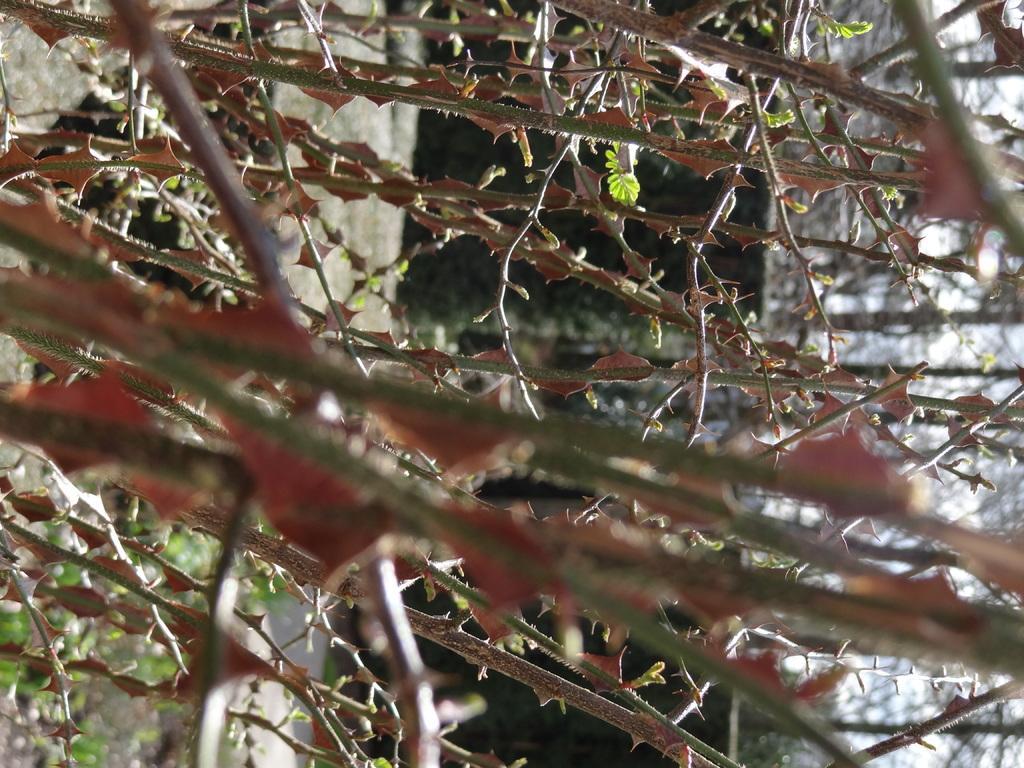Describe this image in one or two sentences. This picture shows trees and we see thorns to the stems. 